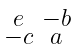<formula> <loc_0><loc_0><loc_500><loc_500>\begin{smallmatrix} e & - b \\ - c & a \end{smallmatrix}</formula> 